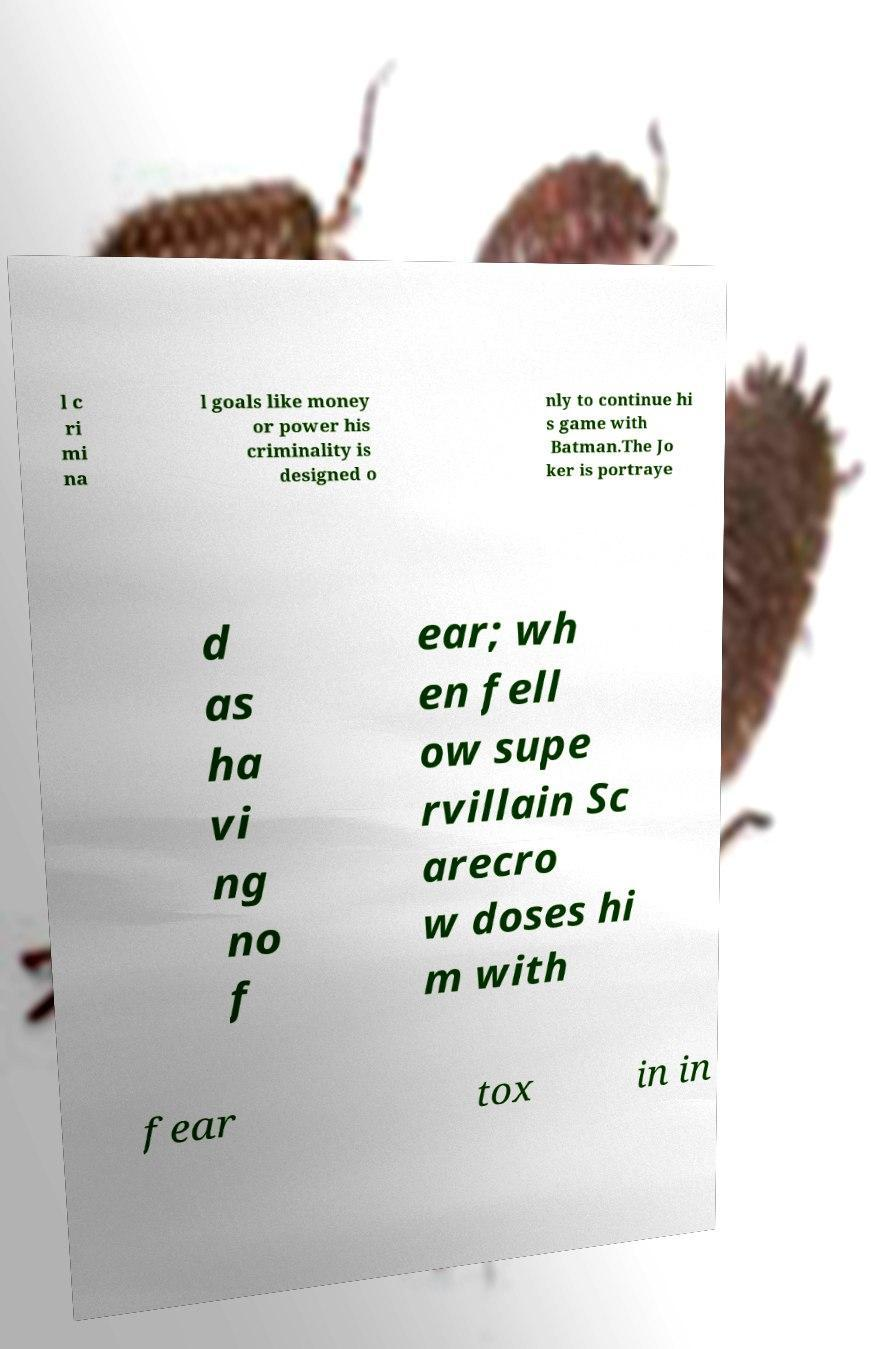Can you accurately transcribe the text from the provided image for me? l c ri mi na l goals like money or power his criminality is designed o nly to continue hi s game with Batman.The Jo ker is portraye d as ha vi ng no f ear; wh en fell ow supe rvillain Sc arecro w doses hi m with fear tox in in 